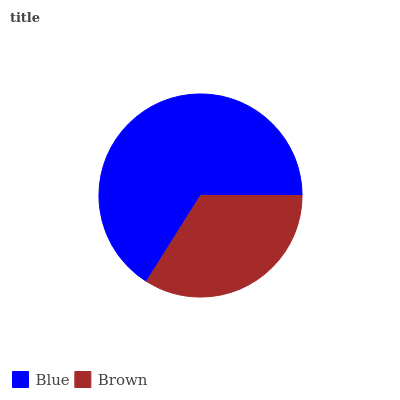Is Brown the minimum?
Answer yes or no. Yes. Is Blue the maximum?
Answer yes or no. Yes. Is Brown the maximum?
Answer yes or no. No. Is Blue greater than Brown?
Answer yes or no. Yes. Is Brown less than Blue?
Answer yes or no. Yes. Is Brown greater than Blue?
Answer yes or no. No. Is Blue less than Brown?
Answer yes or no. No. Is Blue the high median?
Answer yes or no. Yes. Is Brown the low median?
Answer yes or no. Yes. Is Brown the high median?
Answer yes or no. No. Is Blue the low median?
Answer yes or no. No. 